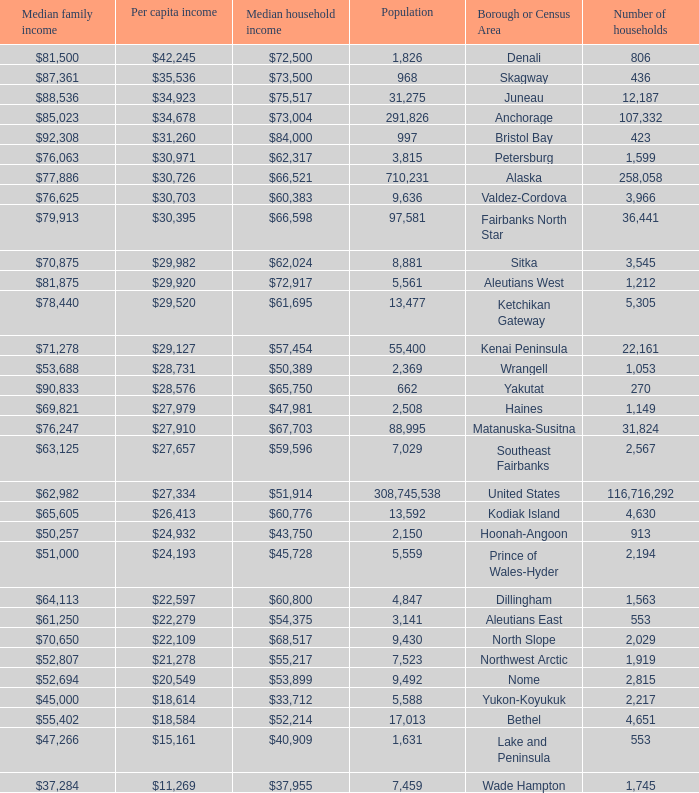What is the population of the area with a median family income of $71,278? 1.0. 